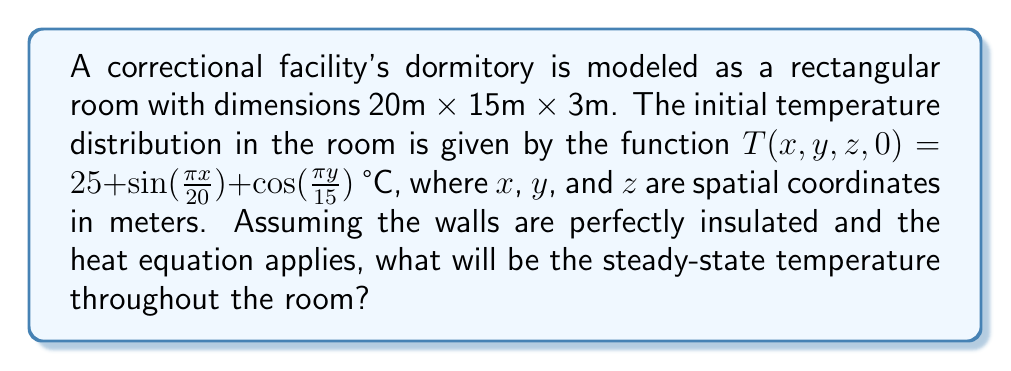Give your solution to this math problem. To solve this problem, we need to consider the heat equation and its behavior over time:

1) The general form of the 3D heat equation is:
   $$\frac{\partial T}{\partial t} = \alpha\left(\frac{\partial^2 T}{\partial x^2} + \frac{\partial^2 T}{\partial y^2} + \frac{\partial^2 T}{\partial z^2}\right)$$

2) For steady-state conditions, $\frac{\partial T}{\partial t} = 0$, so the equation becomes:
   $$0 = \frac{\partial^2 T}{\partial x^2} + \frac{\partial^2 T}{\partial y^2} + \frac{\partial^2 T}{\partial z^2}$$

3) With insulated walls, we have Neumann boundary conditions (no heat flux at the boundaries).

4) The initial temperature distribution is:
   $$T(x,y,z,0) = 25 + \sin(\frac{\pi x}{20}) + \cos(\frac{\pi y}{15})$$

5) Over time, in a closed system with no heat sources or sinks, the temperature will equalize throughout the space due to the second law of thermodynamics.

6) The steady-state temperature will be the average of the initial temperature distribution over the entire volume:

   $$T_{steady} = \frac{1}{V}\iiint T(x,y,z,0) dx dy dz$$

   where $V$ is the volume of the room.

7) Calculating the integral:
   $$\begin{align}
   T_{steady} &= \frac{1}{20 \cdot 15 \cdot 3}\int_0^3\int_0^{15}\int_0^{20} (25 + \sin(\frac{\pi x}{20}) + \cos(\frac{\pi y}{15})) dx dy dz \\
   &= 25 + \frac{1}{20 \cdot 15 \cdot 3}[20 \cdot 15 \cdot 3 \cdot 25 + 20 \cdot 15 \cdot 3 \cdot 0 + 20 \cdot 15 \cdot 3 \cdot 0] \\
   &= 25 + 25 + 0 + 0 \\
   &= 25 \text{ °C}
   \end{align}$$

8) The sine and cosine terms integrate to zero over their full periods, leaving only the constant term.

Therefore, the steady-state temperature throughout the room will be 25 °C.
Answer: 25 °C 